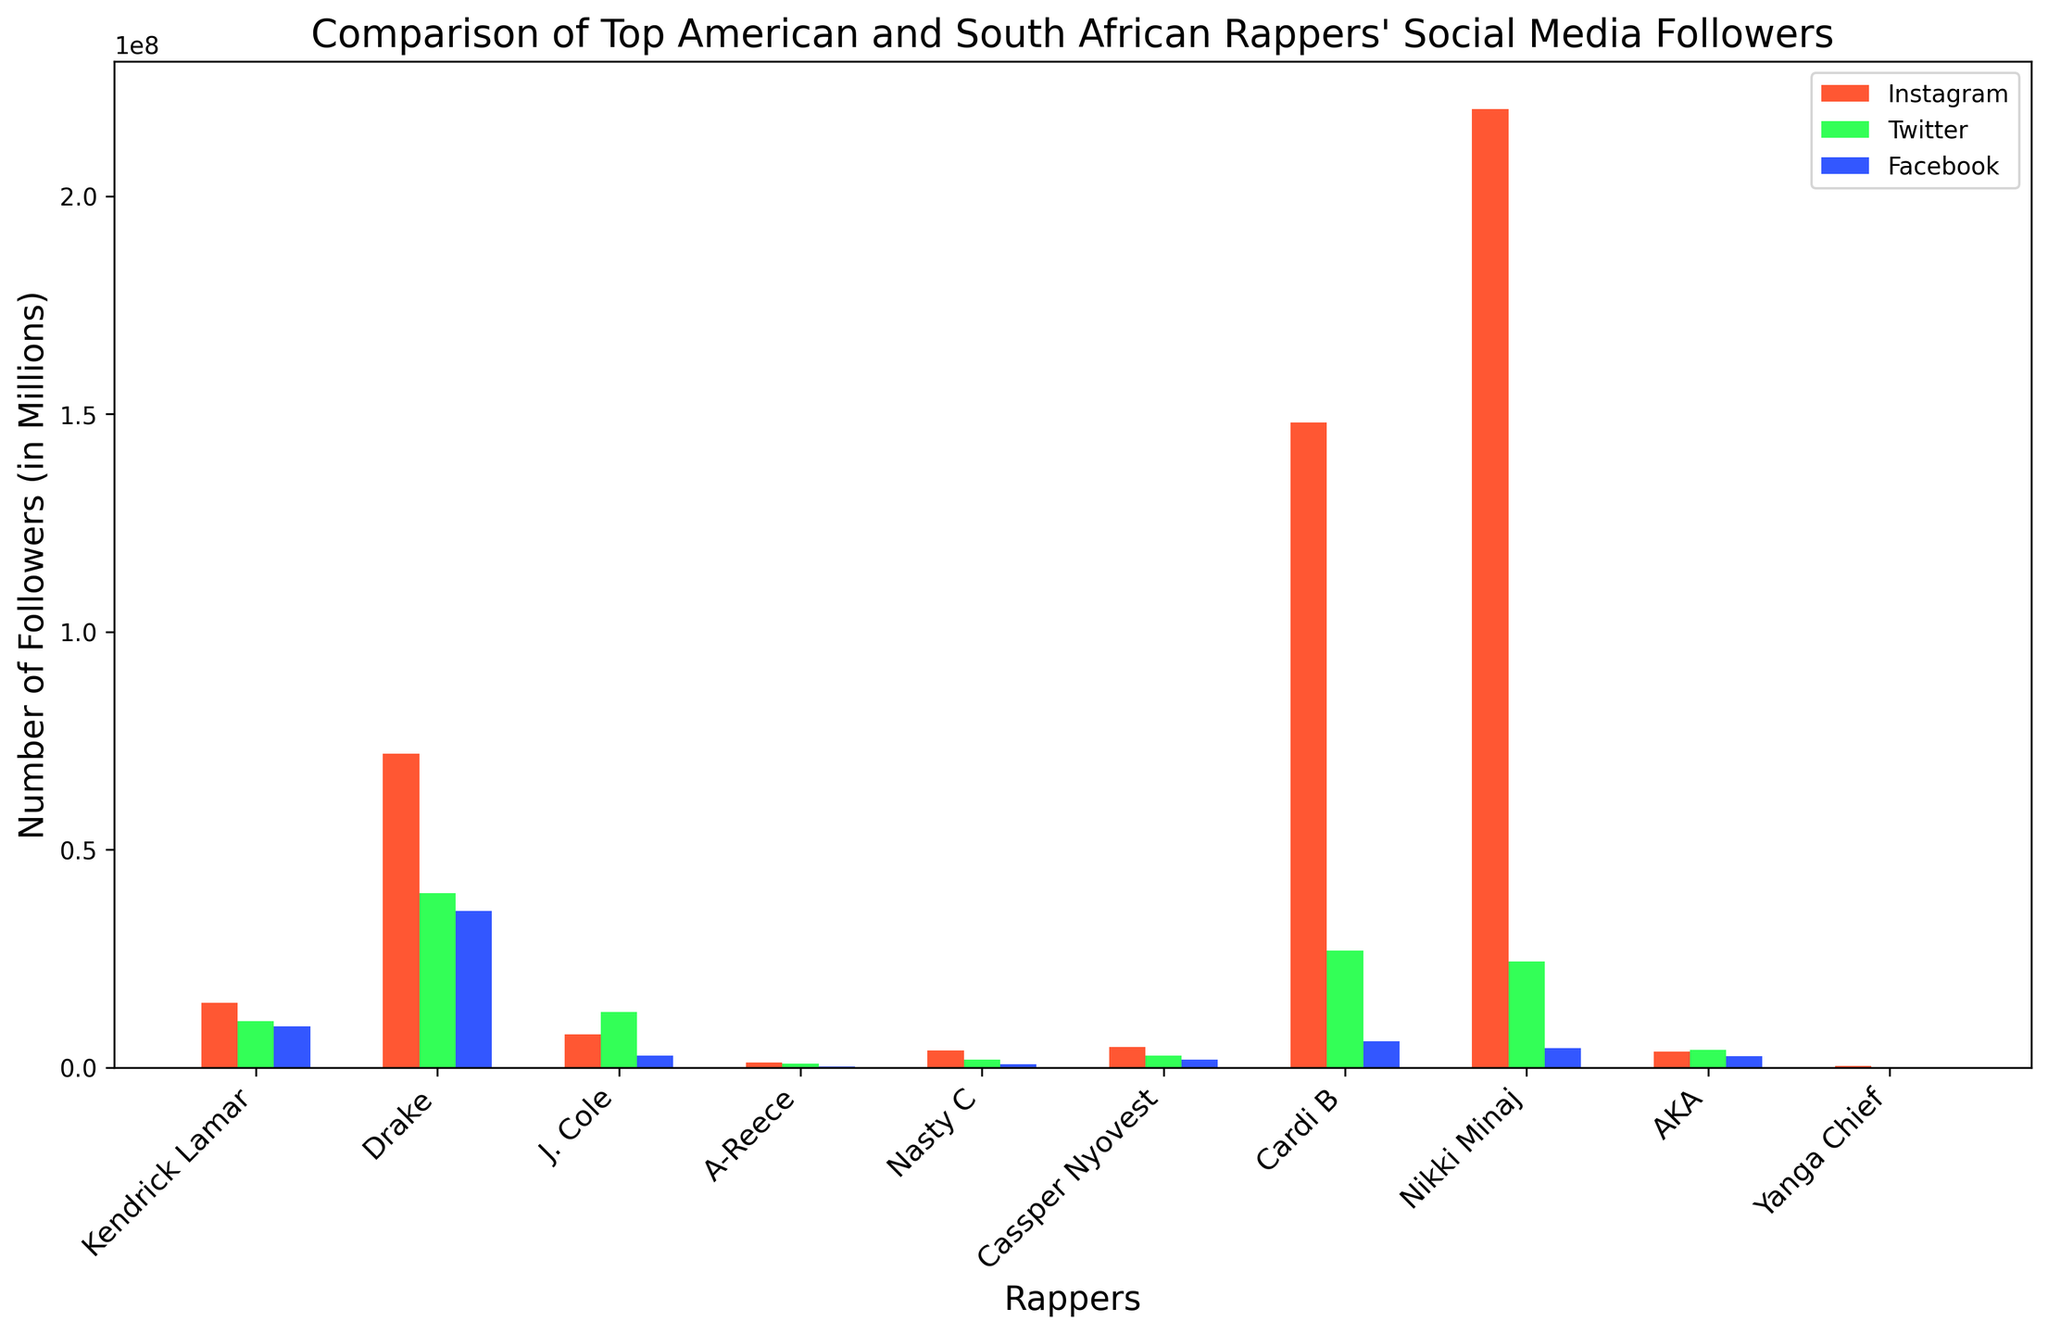Which rapper has the highest number of Instagram followers? The highest bar in the Instagram section corresponds to Nicki Minaj.
Answer: Nicki Minaj How many social media followers does Drake have altogether? Add up Drake's Instagram, Twitter, and Facebook followers: 72,000,000 + 40,000,000 + 36,000,000 = 148,000,000.
Answer: 148,000,000 How much larger is Cardi B's Instagram following compared to Kendrick Lamar's Instagram following? Subtract Kendrick Lamar's Instagram followers from Cardi B's: 148,000,000 - 14,800,000 = 133,200,000.
Answer: 133,200,000 Which South African rapper has the most Twitter followers? The tallest bar in the South African section for Twitter corresponds to AKA.
Answer: AKA Comparing J. Cole and Cassper Nyovest, who has more followers on Facebook? J. Cole has 2,800,000 followers on Facebook, whereas Cassper Nyovest has 1,800,000 followers. J. Cole has more.
Answer: J. Cole Among South African rappers, who has the least number of Instagram followers? The shortest bar in the South African section for Instagram corresponds to Yanga Chief.
Answer: Yanga Chief Which American rapper has the highest number of Facebook followers? The tallest bar in the American section for Facebook corresponds to Drake.
Answer: Drake What is the total number of Twitter followers for all South African rappers combined? Sum the Twitter followers for A-Reece, Nasty C, Cassper Nyovest, AKA, and Yanga Chief: 890,000 + 1,800,000 + 2,800,000 + 4,000,000 + 130,000 = 9,620,000.
Answer: 9,620,000 How does Nasty C's total number of social media followers compare to J. Cole's? Add up their followers:
Nasty C: 3,900,000 (Instagram) + 1,800,000 (Twitter) + 720,000 (Facebook) = 6,420,000.
J. Cole: 7,600,000 (Instagram) + 12,700,000 (Twitter) + 2,800,000 (Facebook) = 23,100,000.
J. Cole has more total followers.
Answer: J. Cole Which social media platform shows the least disparity among the followers of all the rappers? By visually comparing the heights of all the bars, Twitter followers show the least disparity in bar heights across the rappers.
Answer: Twitter 